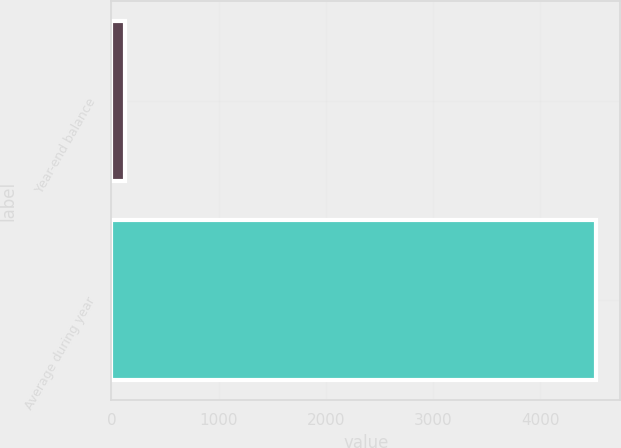Convert chart to OTSL. <chart><loc_0><loc_0><loc_500><loc_500><bar_chart><fcel>Year-end balance<fcel>Average during year<nl><fcel>128<fcel>4518<nl></chart> 